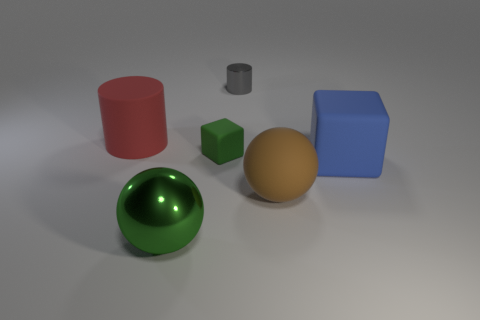Subtract all brown spheres. How many spheres are left? 1 Add 4 big metal things. How many objects exist? 10 Subtract 0 brown cylinders. How many objects are left? 6 Subtract all cylinders. How many objects are left? 4 Subtract 1 cubes. How many cubes are left? 1 Subtract all brown blocks. Subtract all yellow balls. How many blocks are left? 2 Subtract all brown balls. How many red blocks are left? 0 Subtract all small matte cubes. Subtract all small gray metal things. How many objects are left? 4 Add 3 small gray things. How many small gray things are left? 4 Add 4 green blocks. How many green blocks exist? 5 